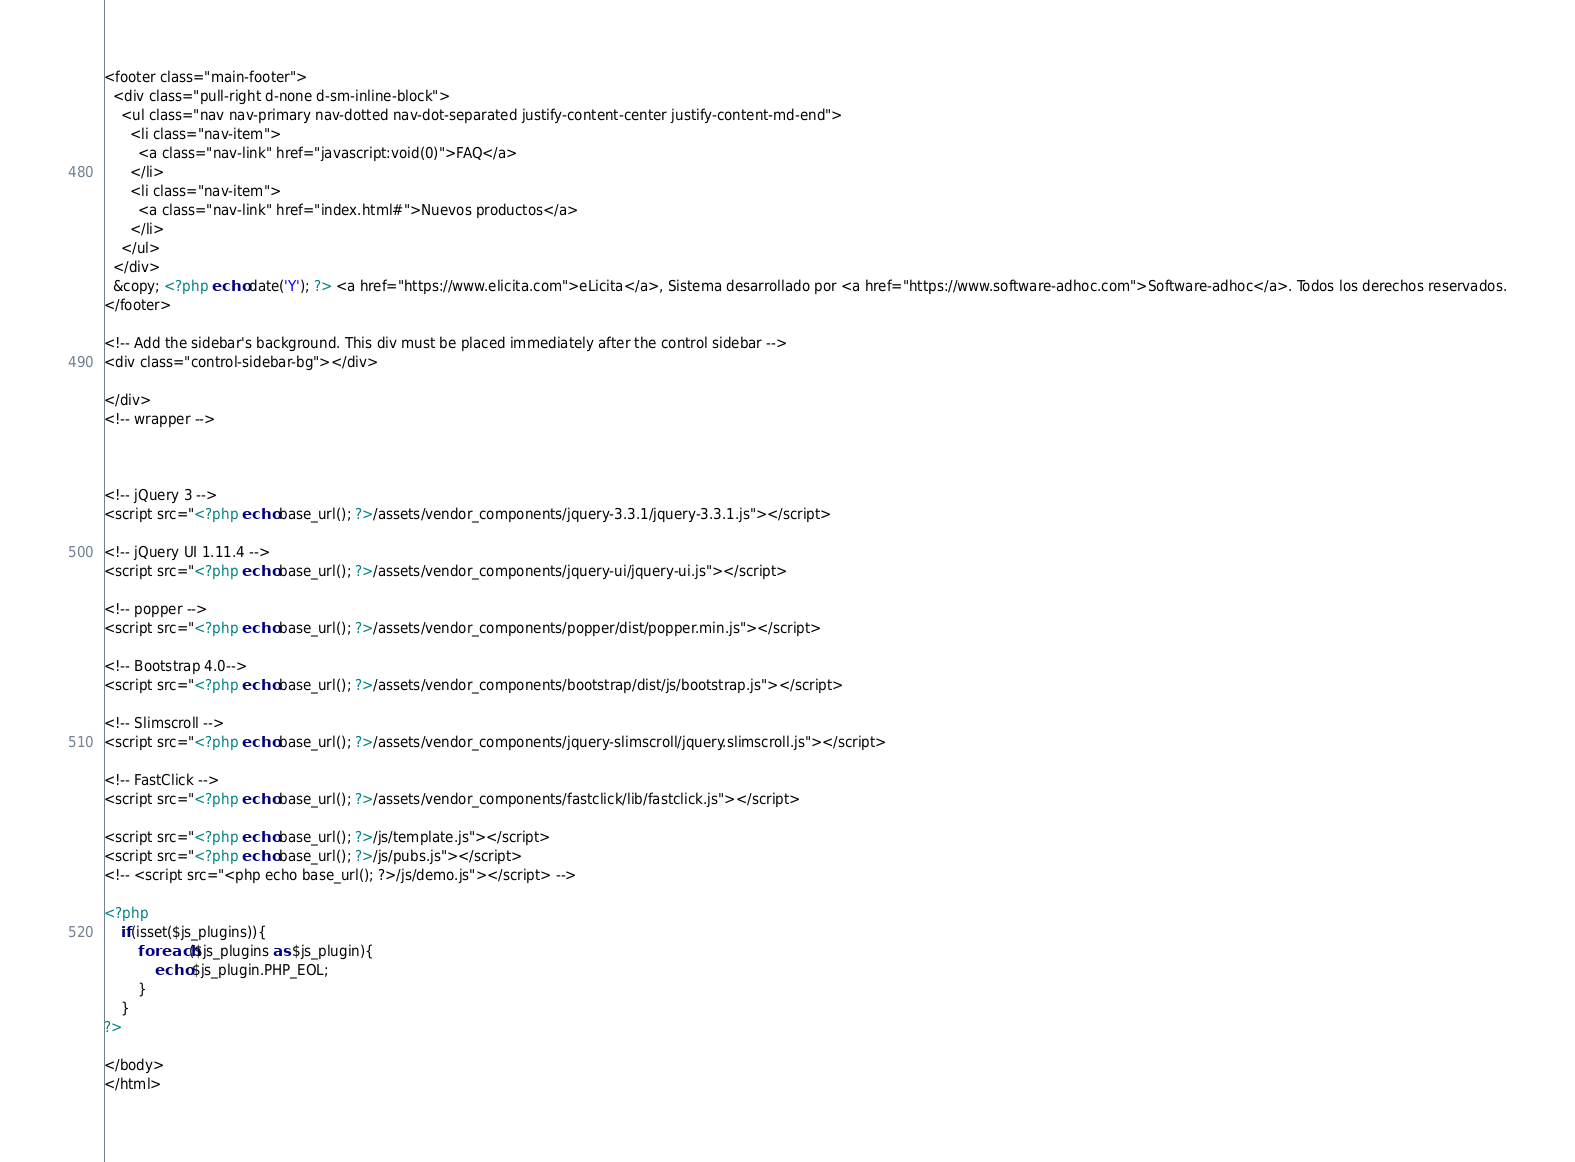Convert code to text. <code><loc_0><loc_0><loc_500><loc_500><_PHP_><footer class="main-footer">
  <div class="pull-right d-none d-sm-inline-block">
    <ul class="nav nav-primary nav-dotted nav-dot-separated justify-content-center justify-content-md-end">
      <li class="nav-item">
        <a class="nav-link" href="javascript:void(0)">FAQ</a>
      </li>
      <li class="nav-item">
        <a class="nav-link" href="index.html#">Nuevos productos</a>
      </li>
    </ul>
  </div>
  &copy; <?php echo date('Y'); ?> <a href="https://www.elicita.com">eLicita</a>, Sistema desarrollado por <a href="https://www.software-adhoc.com">Software-adhoc</a>. Todos los derechos reservados.
</footer>

<!-- Add the sidebar's background. This div must be placed immediately after the control sidebar -->
<div class="control-sidebar-bg"></div>

</div>
<!-- wrapper -->



<!-- jQuery 3 -->
<script src="<?php echo base_url(); ?>/assets/vendor_components/jquery-3.3.1/jquery-3.3.1.js"></script>

<!-- jQuery UI 1.11.4 -->
<script src="<?php echo base_url(); ?>/assets/vendor_components/jquery-ui/jquery-ui.js"></script>

<!-- popper -->
<script src="<?php echo base_url(); ?>/assets/vendor_components/popper/dist/popper.min.js"></script>

<!-- Bootstrap 4.0-->
<script src="<?php echo base_url(); ?>/assets/vendor_components/bootstrap/dist/js/bootstrap.js"></script>	

<!-- Slimscroll -->
<script src="<?php echo base_url(); ?>/assets/vendor_components/jquery-slimscroll/jquery.slimscroll.js"></script>

<!-- FastClick -->
<script src="<?php echo base_url(); ?>/assets/vendor_components/fastclick/lib/fastclick.js"></script>

<script src="<?php echo base_url(); ?>/js/template.js"></script> 
<script src="<?php echo base_url(); ?>/js/pubs.js"></script> 
<!-- <script src="<php echo base_url(); ?>/js/demo.js"></script> -->

<?php
    if(isset($js_plugins)){
        foreach($js_plugins as $js_plugin){
            echo $js_plugin.PHP_EOL;
        }
    }
?>

</body>
</html></code> 